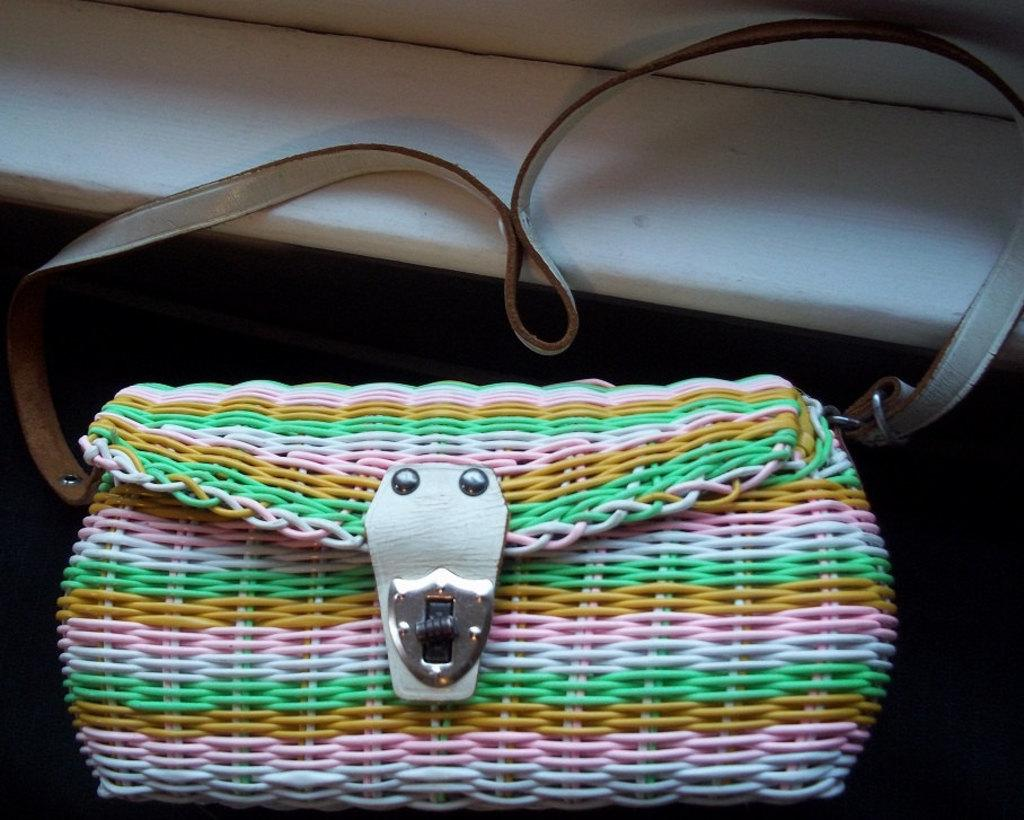What object can be seen in the image? There is a handbag in the image. What is the color of the table in the image? There is a white table in the image. Where was the image taken? The image was taken inside a room. What type of cork can be seen on the floor in the image? There is no cork visible on the floor in the image. 